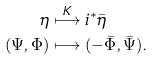<formula> <loc_0><loc_0><loc_500><loc_500>\eta & \stackrel { K } \longmapsto i ^ { * } \bar { \eta } \\ ( \Psi , \Phi ) & \longmapsto ( - \bar { \Phi } , \bar { \Psi } ) .</formula> 